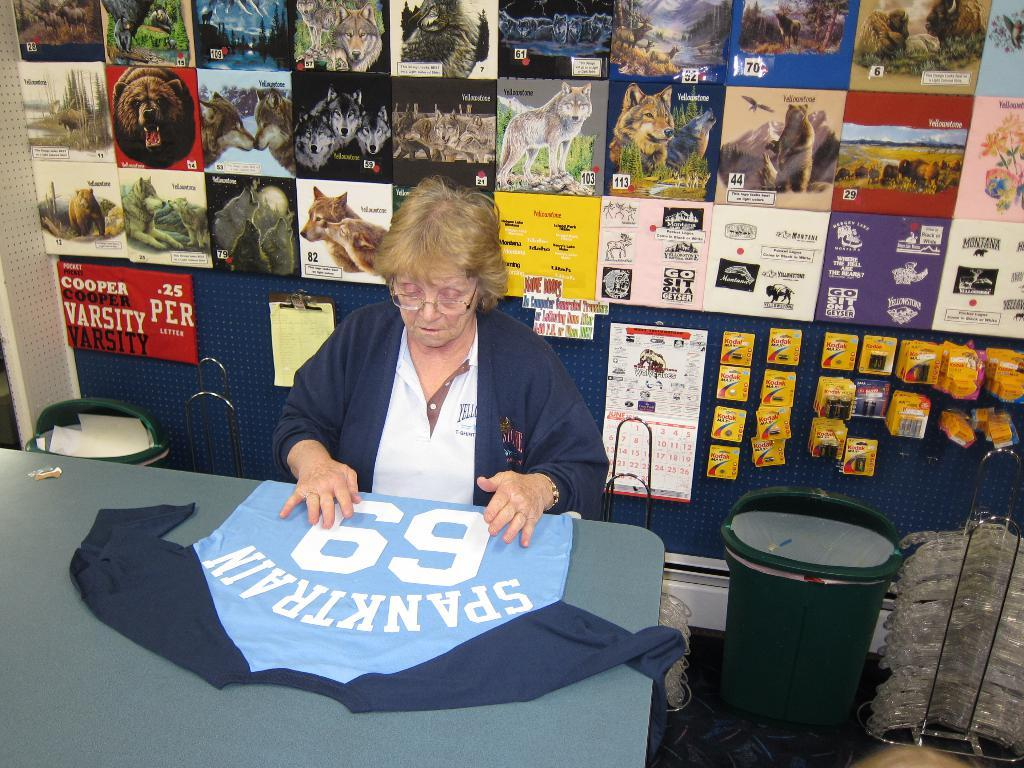<image>
Give a short and clear explanation of the subsequent image. A woman sits at a table with a blue jersey with the number 69. 